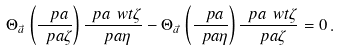Convert formula to latex. <formula><loc_0><loc_0><loc_500><loc_500>\Theta _ { \vec { a } } \, \left ( \frac { \ p a } { \ p a \zeta } \right ) \frac { \ p a \ w t { \zeta } } { \ p a \eta } - \Theta _ { \vec { a } } \, \left ( \frac { \ p a } { \ p a \eta } \right ) \frac { \ p a \ w t { \zeta } } { \ p a \zeta } = 0 \, .</formula> 